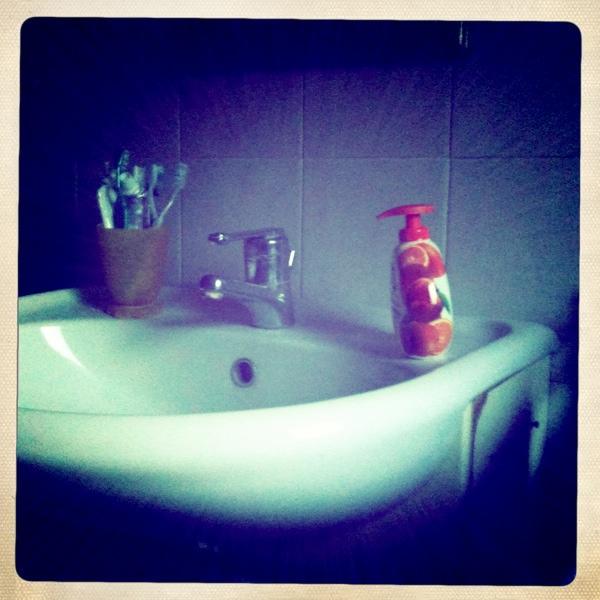Why is there soap on the sink?
Answer briefly. To wash hands. Is the water running?
Quick response, please. No. What is clustered together in the cup?
Be succinct. Toothbrushes. 